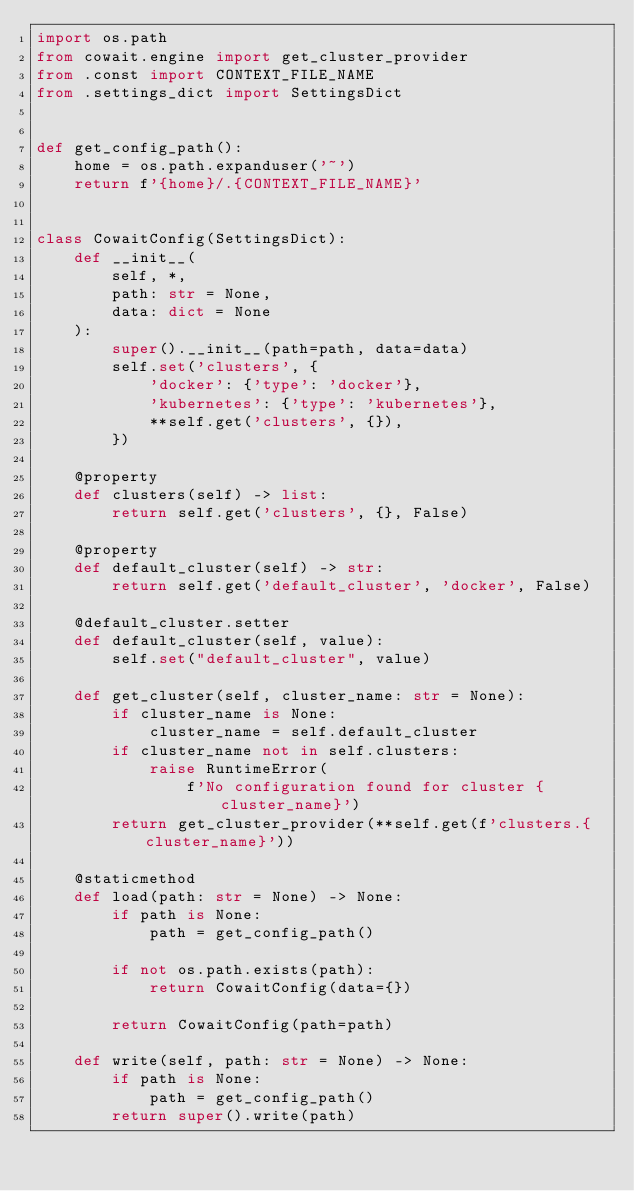Convert code to text. <code><loc_0><loc_0><loc_500><loc_500><_Python_>import os.path
from cowait.engine import get_cluster_provider
from .const import CONTEXT_FILE_NAME
from .settings_dict import SettingsDict


def get_config_path():
    home = os.path.expanduser('~')
    return f'{home}/.{CONTEXT_FILE_NAME}'


class CowaitConfig(SettingsDict):
    def __init__(
        self, *,
        path: str = None,
        data: dict = None
    ):
        super().__init__(path=path, data=data)
        self.set('clusters', {
            'docker': {'type': 'docker'},
            'kubernetes': {'type': 'kubernetes'},
            **self.get('clusters', {}),
        })

    @property
    def clusters(self) -> list:
        return self.get('clusters', {}, False)

    @property
    def default_cluster(self) -> str:
        return self.get('default_cluster', 'docker', False)
    
    @default_cluster.setter
    def default_cluster(self, value):
        self.set("default_cluster", value)

    def get_cluster(self, cluster_name: str = None):
        if cluster_name is None:
            cluster_name = self.default_cluster
        if cluster_name not in self.clusters:
            raise RuntimeError(
                f'No configuration found for cluster {cluster_name}')
        return get_cluster_provider(**self.get(f'clusters.{cluster_name}'))

    @staticmethod
    def load(path: str = None) -> None:
        if path is None:
            path = get_config_path()

        if not os.path.exists(path):
            return CowaitConfig(data={})

        return CowaitConfig(path=path)

    def write(self, path: str = None) -> None:
        if path is None:
            path = get_config_path()
        return super().write(path)
</code> 